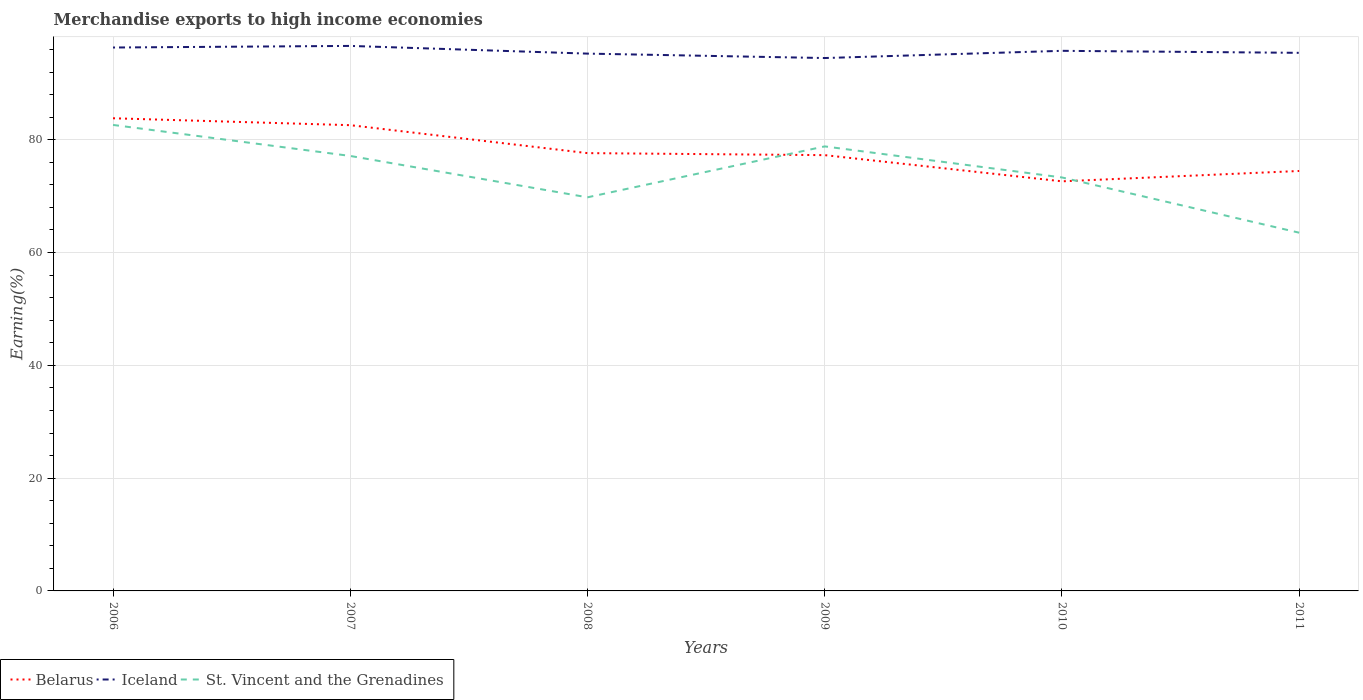How many different coloured lines are there?
Your answer should be very brief. 3. Does the line corresponding to Iceland intersect with the line corresponding to Belarus?
Give a very brief answer. No. Is the number of lines equal to the number of legend labels?
Provide a short and direct response. Yes. Across all years, what is the maximum percentage of amount earned from merchandise exports in Iceland?
Ensure brevity in your answer.  94.49. What is the total percentage of amount earned from merchandise exports in St. Vincent and the Grenadines in the graph?
Give a very brief answer. 19.11. What is the difference between the highest and the second highest percentage of amount earned from merchandise exports in Belarus?
Offer a very short reply. 11.18. What is the difference between the highest and the lowest percentage of amount earned from merchandise exports in Belarus?
Provide a short and direct response. 2. Are the values on the major ticks of Y-axis written in scientific E-notation?
Your response must be concise. No. Does the graph contain any zero values?
Your answer should be very brief. No. What is the title of the graph?
Provide a succinct answer. Merchandise exports to high income economies. What is the label or title of the Y-axis?
Give a very brief answer. Earning(%). What is the Earning(%) in Belarus in 2006?
Offer a terse response. 83.81. What is the Earning(%) in Iceland in 2006?
Provide a short and direct response. 96.35. What is the Earning(%) in St. Vincent and the Grenadines in 2006?
Ensure brevity in your answer.  82.63. What is the Earning(%) in Belarus in 2007?
Ensure brevity in your answer.  82.58. What is the Earning(%) of Iceland in 2007?
Offer a very short reply. 96.64. What is the Earning(%) in St. Vincent and the Grenadines in 2007?
Your answer should be very brief. 77.13. What is the Earning(%) of Belarus in 2008?
Your answer should be compact. 77.63. What is the Earning(%) in Iceland in 2008?
Your answer should be very brief. 95.27. What is the Earning(%) of St. Vincent and the Grenadines in 2008?
Your answer should be very brief. 69.79. What is the Earning(%) of Belarus in 2009?
Ensure brevity in your answer.  77.27. What is the Earning(%) in Iceland in 2009?
Offer a terse response. 94.49. What is the Earning(%) in St. Vincent and the Grenadines in 2009?
Your answer should be compact. 78.82. What is the Earning(%) of Belarus in 2010?
Provide a short and direct response. 72.63. What is the Earning(%) in Iceland in 2010?
Provide a short and direct response. 95.77. What is the Earning(%) in St. Vincent and the Grenadines in 2010?
Ensure brevity in your answer.  73.31. What is the Earning(%) in Belarus in 2011?
Your response must be concise. 74.46. What is the Earning(%) in Iceland in 2011?
Provide a short and direct response. 95.41. What is the Earning(%) of St. Vincent and the Grenadines in 2011?
Provide a short and direct response. 63.52. Across all years, what is the maximum Earning(%) of Belarus?
Give a very brief answer. 83.81. Across all years, what is the maximum Earning(%) in Iceland?
Your response must be concise. 96.64. Across all years, what is the maximum Earning(%) in St. Vincent and the Grenadines?
Your response must be concise. 82.63. Across all years, what is the minimum Earning(%) of Belarus?
Offer a terse response. 72.63. Across all years, what is the minimum Earning(%) in Iceland?
Offer a terse response. 94.49. Across all years, what is the minimum Earning(%) in St. Vincent and the Grenadines?
Keep it short and to the point. 63.52. What is the total Earning(%) of Belarus in the graph?
Give a very brief answer. 468.38. What is the total Earning(%) in Iceland in the graph?
Give a very brief answer. 573.92. What is the total Earning(%) of St. Vincent and the Grenadines in the graph?
Keep it short and to the point. 445.19. What is the difference between the Earning(%) of Belarus in 2006 and that in 2007?
Keep it short and to the point. 1.23. What is the difference between the Earning(%) of Iceland in 2006 and that in 2007?
Provide a succinct answer. -0.28. What is the difference between the Earning(%) in St. Vincent and the Grenadines in 2006 and that in 2007?
Offer a very short reply. 5.5. What is the difference between the Earning(%) in Belarus in 2006 and that in 2008?
Offer a terse response. 6.18. What is the difference between the Earning(%) in Iceland in 2006 and that in 2008?
Your answer should be very brief. 1.08. What is the difference between the Earning(%) in St. Vincent and the Grenadines in 2006 and that in 2008?
Offer a terse response. 12.84. What is the difference between the Earning(%) in Belarus in 2006 and that in 2009?
Offer a very short reply. 6.54. What is the difference between the Earning(%) in Iceland in 2006 and that in 2009?
Keep it short and to the point. 1.87. What is the difference between the Earning(%) in St. Vincent and the Grenadines in 2006 and that in 2009?
Your answer should be compact. 3.81. What is the difference between the Earning(%) in Belarus in 2006 and that in 2010?
Offer a very short reply. 11.18. What is the difference between the Earning(%) in Iceland in 2006 and that in 2010?
Your answer should be very brief. 0.59. What is the difference between the Earning(%) of St. Vincent and the Grenadines in 2006 and that in 2010?
Provide a succinct answer. 9.31. What is the difference between the Earning(%) in Belarus in 2006 and that in 2011?
Your response must be concise. 9.35. What is the difference between the Earning(%) of Iceland in 2006 and that in 2011?
Your answer should be very brief. 0.94. What is the difference between the Earning(%) of St. Vincent and the Grenadines in 2006 and that in 2011?
Make the answer very short. 19.11. What is the difference between the Earning(%) of Belarus in 2007 and that in 2008?
Provide a short and direct response. 4.96. What is the difference between the Earning(%) of Iceland in 2007 and that in 2008?
Make the answer very short. 1.37. What is the difference between the Earning(%) of St. Vincent and the Grenadines in 2007 and that in 2008?
Your answer should be compact. 7.34. What is the difference between the Earning(%) of Belarus in 2007 and that in 2009?
Make the answer very short. 5.31. What is the difference between the Earning(%) in Iceland in 2007 and that in 2009?
Provide a short and direct response. 2.15. What is the difference between the Earning(%) in St. Vincent and the Grenadines in 2007 and that in 2009?
Give a very brief answer. -1.69. What is the difference between the Earning(%) in Belarus in 2007 and that in 2010?
Provide a short and direct response. 9.96. What is the difference between the Earning(%) of Iceland in 2007 and that in 2010?
Your answer should be compact. 0.87. What is the difference between the Earning(%) of St. Vincent and the Grenadines in 2007 and that in 2010?
Your answer should be compact. 3.81. What is the difference between the Earning(%) in Belarus in 2007 and that in 2011?
Offer a terse response. 8.12. What is the difference between the Earning(%) in Iceland in 2007 and that in 2011?
Keep it short and to the point. 1.23. What is the difference between the Earning(%) of St. Vincent and the Grenadines in 2007 and that in 2011?
Make the answer very short. 13.61. What is the difference between the Earning(%) of Belarus in 2008 and that in 2009?
Provide a short and direct response. 0.36. What is the difference between the Earning(%) of Iceland in 2008 and that in 2009?
Ensure brevity in your answer.  0.78. What is the difference between the Earning(%) in St. Vincent and the Grenadines in 2008 and that in 2009?
Keep it short and to the point. -9.03. What is the difference between the Earning(%) of Belarus in 2008 and that in 2010?
Your answer should be very brief. 5. What is the difference between the Earning(%) in Iceland in 2008 and that in 2010?
Ensure brevity in your answer.  -0.49. What is the difference between the Earning(%) of St. Vincent and the Grenadines in 2008 and that in 2010?
Ensure brevity in your answer.  -3.52. What is the difference between the Earning(%) of Belarus in 2008 and that in 2011?
Offer a very short reply. 3.17. What is the difference between the Earning(%) of Iceland in 2008 and that in 2011?
Your answer should be very brief. -0.14. What is the difference between the Earning(%) of St. Vincent and the Grenadines in 2008 and that in 2011?
Your answer should be compact. 6.27. What is the difference between the Earning(%) of Belarus in 2009 and that in 2010?
Provide a short and direct response. 4.64. What is the difference between the Earning(%) of Iceland in 2009 and that in 2010?
Your answer should be compact. -1.28. What is the difference between the Earning(%) of St. Vincent and the Grenadines in 2009 and that in 2010?
Ensure brevity in your answer.  5.51. What is the difference between the Earning(%) of Belarus in 2009 and that in 2011?
Your response must be concise. 2.81. What is the difference between the Earning(%) in Iceland in 2009 and that in 2011?
Make the answer very short. -0.92. What is the difference between the Earning(%) of St. Vincent and the Grenadines in 2009 and that in 2011?
Your response must be concise. 15.3. What is the difference between the Earning(%) in Belarus in 2010 and that in 2011?
Keep it short and to the point. -1.83. What is the difference between the Earning(%) of Iceland in 2010 and that in 2011?
Your answer should be very brief. 0.36. What is the difference between the Earning(%) in St. Vincent and the Grenadines in 2010 and that in 2011?
Provide a short and direct response. 9.8. What is the difference between the Earning(%) in Belarus in 2006 and the Earning(%) in Iceland in 2007?
Keep it short and to the point. -12.83. What is the difference between the Earning(%) in Belarus in 2006 and the Earning(%) in St. Vincent and the Grenadines in 2007?
Your answer should be very brief. 6.68. What is the difference between the Earning(%) in Iceland in 2006 and the Earning(%) in St. Vincent and the Grenadines in 2007?
Give a very brief answer. 19.23. What is the difference between the Earning(%) in Belarus in 2006 and the Earning(%) in Iceland in 2008?
Your response must be concise. -11.46. What is the difference between the Earning(%) in Belarus in 2006 and the Earning(%) in St. Vincent and the Grenadines in 2008?
Offer a very short reply. 14.02. What is the difference between the Earning(%) of Iceland in 2006 and the Earning(%) of St. Vincent and the Grenadines in 2008?
Provide a succinct answer. 26.56. What is the difference between the Earning(%) of Belarus in 2006 and the Earning(%) of Iceland in 2009?
Your answer should be compact. -10.68. What is the difference between the Earning(%) of Belarus in 2006 and the Earning(%) of St. Vincent and the Grenadines in 2009?
Provide a succinct answer. 4.99. What is the difference between the Earning(%) of Iceland in 2006 and the Earning(%) of St. Vincent and the Grenadines in 2009?
Ensure brevity in your answer.  17.53. What is the difference between the Earning(%) in Belarus in 2006 and the Earning(%) in Iceland in 2010?
Your response must be concise. -11.96. What is the difference between the Earning(%) in Belarus in 2006 and the Earning(%) in St. Vincent and the Grenadines in 2010?
Keep it short and to the point. 10.49. What is the difference between the Earning(%) in Iceland in 2006 and the Earning(%) in St. Vincent and the Grenadines in 2010?
Your response must be concise. 23.04. What is the difference between the Earning(%) of Belarus in 2006 and the Earning(%) of Iceland in 2011?
Your answer should be very brief. -11.6. What is the difference between the Earning(%) in Belarus in 2006 and the Earning(%) in St. Vincent and the Grenadines in 2011?
Offer a terse response. 20.29. What is the difference between the Earning(%) of Iceland in 2006 and the Earning(%) of St. Vincent and the Grenadines in 2011?
Your answer should be very brief. 32.84. What is the difference between the Earning(%) in Belarus in 2007 and the Earning(%) in Iceland in 2008?
Give a very brief answer. -12.69. What is the difference between the Earning(%) in Belarus in 2007 and the Earning(%) in St. Vincent and the Grenadines in 2008?
Provide a short and direct response. 12.79. What is the difference between the Earning(%) of Iceland in 2007 and the Earning(%) of St. Vincent and the Grenadines in 2008?
Make the answer very short. 26.85. What is the difference between the Earning(%) in Belarus in 2007 and the Earning(%) in Iceland in 2009?
Your answer should be compact. -11.9. What is the difference between the Earning(%) of Belarus in 2007 and the Earning(%) of St. Vincent and the Grenadines in 2009?
Keep it short and to the point. 3.76. What is the difference between the Earning(%) in Iceland in 2007 and the Earning(%) in St. Vincent and the Grenadines in 2009?
Make the answer very short. 17.82. What is the difference between the Earning(%) in Belarus in 2007 and the Earning(%) in Iceland in 2010?
Offer a very short reply. -13.18. What is the difference between the Earning(%) of Belarus in 2007 and the Earning(%) of St. Vincent and the Grenadines in 2010?
Make the answer very short. 9.27. What is the difference between the Earning(%) of Iceland in 2007 and the Earning(%) of St. Vincent and the Grenadines in 2010?
Provide a succinct answer. 23.32. What is the difference between the Earning(%) in Belarus in 2007 and the Earning(%) in Iceland in 2011?
Make the answer very short. -12.83. What is the difference between the Earning(%) of Belarus in 2007 and the Earning(%) of St. Vincent and the Grenadines in 2011?
Your answer should be compact. 19.07. What is the difference between the Earning(%) of Iceland in 2007 and the Earning(%) of St. Vincent and the Grenadines in 2011?
Ensure brevity in your answer.  33.12. What is the difference between the Earning(%) in Belarus in 2008 and the Earning(%) in Iceland in 2009?
Offer a very short reply. -16.86. What is the difference between the Earning(%) of Belarus in 2008 and the Earning(%) of St. Vincent and the Grenadines in 2009?
Your answer should be very brief. -1.19. What is the difference between the Earning(%) in Iceland in 2008 and the Earning(%) in St. Vincent and the Grenadines in 2009?
Keep it short and to the point. 16.45. What is the difference between the Earning(%) of Belarus in 2008 and the Earning(%) of Iceland in 2010?
Offer a terse response. -18.14. What is the difference between the Earning(%) in Belarus in 2008 and the Earning(%) in St. Vincent and the Grenadines in 2010?
Make the answer very short. 4.31. What is the difference between the Earning(%) of Iceland in 2008 and the Earning(%) of St. Vincent and the Grenadines in 2010?
Keep it short and to the point. 21.96. What is the difference between the Earning(%) of Belarus in 2008 and the Earning(%) of Iceland in 2011?
Your answer should be very brief. -17.78. What is the difference between the Earning(%) of Belarus in 2008 and the Earning(%) of St. Vincent and the Grenadines in 2011?
Provide a short and direct response. 14.11. What is the difference between the Earning(%) of Iceland in 2008 and the Earning(%) of St. Vincent and the Grenadines in 2011?
Offer a very short reply. 31.75. What is the difference between the Earning(%) of Belarus in 2009 and the Earning(%) of Iceland in 2010?
Your answer should be very brief. -18.5. What is the difference between the Earning(%) in Belarus in 2009 and the Earning(%) in St. Vincent and the Grenadines in 2010?
Provide a succinct answer. 3.96. What is the difference between the Earning(%) of Iceland in 2009 and the Earning(%) of St. Vincent and the Grenadines in 2010?
Make the answer very short. 21.17. What is the difference between the Earning(%) in Belarus in 2009 and the Earning(%) in Iceland in 2011?
Make the answer very short. -18.14. What is the difference between the Earning(%) of Belarus in 2009 and the Earning(%) of St. Vincent and the Grenadines in 2011?
Keep it short and to the point. 13.75. What is the difference between the Earning(%) of Iceland in 2009 and the Earning(%) of St. Vincent and the Grenadines in 2011?
Your answer should be very brief. 30.97. What is the difference between the Earning(%) of Belarus in 2010 and the Earning(%) of Iceland in 2011?
Your answer should be very brief. -22.78. What is the difference between the Earning(%) of Belarus in 2010 and the Earning(%) of St. Vincent and the Grenadines in 2011?
Make the answer very short. 9.11. What is the difference between the Earning(%) of Iceland in 2010 and the Earning(%) of St. Vincent and the Grenadines in 2011?
Offer a very short reply. 32.25. What is the average Earning(%) of Belarus per year?
Offer a terse response. 78.06. What is the average Earning(%) in Iceland per year?
Provide a succinct answer. 95.65. What is the average Earning(%) of St. Vincent and the Grenadines per year?
Provide a succinct answer. 74.2. In the year 2006, what is the difference between the Earning(%) of Belarus and Earning(%) of Iceland?
Your response must be concise. -12.54. In the year 2006, what is the difference between the Earning(%) of Belarus and Earning(%) of St. Vincent and the Grenadines?
Your answer should be very brief. 1.18. In the year 2006, what is the difference between the Earning(%) in Iceland and Earning(%) in St. Vincent and the Grenadines?
Offer a terse response. 13.73. In the year 2007, what is the difference between the Earning(%) in Belarus and Earning(%) in Iceland?
Provide a short and direct response. -14.05. In the year 2007, what is the difference between the Earning(%) of Belarus and Earning(%) of St. Vincent and the Grenadines?
Provide a succinct answer. 5.46. In the year 2007, what is the difference between the Earning(%) of Iceland and Earning(%) of St. Vincent and the Grenadines?
Provide a succinct answer. 19.51. In the year 2008, what is the difference between the Earning(%) of Belarus and Earning(%) of Iceland?
Make the answer very short. -17.64. In the year 2008, what is the difference between the Earning(%) in Belarus and Earning(%) in St. Vincent and the Grenadines?
Offer a terse response. 7.84. In the year 2008, what is the difference between the Earning(%) of Iceland and Earning(%) of St. Vincent and the Grenadines?
Your answer should be compact. 25.48. In the year 2009, what is the difference between the Earning(%) of Belarus and Earning(%) of Iceland?
Ensure brevity in your answer.  -17.22. In the year 2009, what is the difference between the Earning(%) of Belarus and Earning(%) of St. Vincent and the Grenadines?
Give a very brief answer. -1.55. In the year 2009, what is the difference between the Earning(%) of Iceland and Earning(%) of St. Vincent and the Grenadines?
Give a very brief answer. 15.67. In the year 2010, what is the difference between the Earning(%) of Belarus and Earning(%) of Iceland?
Ensure brevity in your answer.  -23.14. In the year 2010, what is the difference between the Earning(%) of Belarus and Earning(%) of St. Vincent and the Grenadines?
Provide a short and direct response. -0.69. In the year 2010, what is the difference between the Earning(%) of Iceland and Earning(%) of St. Vincent and the Grenadines?
Your answer should be compact. 22.45. In the year 2011, what is the difference between the Earning(%) in Belarus and Earning(%) in Iceland?
Your answer should be compact. -20.95. In the year 2011, what is the difference between the Earning(%) in Belarus and Earning(%) in St. Vincent and the Grenadines?
Keep it short and to the point. 10.94. In the year 2011, what is the difference between the Earning(%) of Iceland and Earning(%) of St. Vincent and the Grenadines?
Your answer should be compact. 31.89. What is the ratio of the Earning(%) of Belarus in 2006 to that in 2007?
Offer a very short reply. 1.01. What is the ratio of the Earning(%) of Iceland in 2006 to that in 2007?
Make the answer very short. 1. What is the ratio of the Earning(%) in St. Vincent and the Grenadines in 2006 to that in 2007?
Your answer should be very brief. 1.07. What is the ratio of the Earning(%) in Belarus in 2006 to that in 2008?
Your answer should be compact. 1.08. What is the ratio of the Earning(%) of Iceland in 2006 to that in 2008?
Provide a short and direct response. 1.01. What is the ratio of the Earning(%) in St. Vincent and the Grenadines in 2006 to that in 2008?
Give a very brief answer. 1.18. What is the ratio of the Earning(%) of Belarus in 2006 to that in 2009?
Provide a short and direct response. 1.08. What is the ratio of the Earning(%) of Iceland in 2006 to that in 2009?
Give a very brief answer. 1.02. What is the ratio of the Earning(%) in St. Vincent and the Grenadines in 2006 to that in 2009?
Your answer should be compact. 1.05. What is the ratio of the Earning(%) of Belarus in 2006 to that in 2010?
Your answer should be very brief. 1.15. What is the ratio of the Earning(%) in St. Vincent and the Grenadines in 2006 to that in 2010?
Make the answer very short. 1.13. What is the ratio of the Earning(%) in Belarus in 2006 to that in 2011?
Offer a terse response. 1.13. What is the ratio of the Earning(%) of Iceland in 2006 to that in 2011?
Provide a short and direct response. 1.01. What is the ratio of the Earning(%) in St. Vincent and the Grenadines in 2006 to that in 2011?
Provide a succinct answer. 1.3. What is the ratio of the Earning(%) in Belarus in 2007 to that in 2008?
Provide a succinct answer. 1.06. What is the ratio of the Earning(%) in Iceland in 2007 to that in 2008?
Give a very brief answer. 1.01. What is the ratio of the Earning(%) of St. Vincent and the Grenadines in 2007 to that in 2008?
Your answer should be very brief. 1.11. What is the ratio of the Earning(%) of Belarus in 2007 to that in 2009?
Ensure brevity in your answer.  1.07. What is the ratio of the Earning(%) of Iceland in 2007 to that in 2009?
Your response must be concise. 1.02. What is the ratio of the Earning(%) of St. Vincent and the Grenadines in 2007 to that in 2009?
Provide a short and direct response. 0.98. What is the ratio of the Earning(%) in Belarus in 2007 to that in 2010?
Your answer should be very brief. 1.14. What is the ratio of the Earning(%) of Iceland in 2007 to that in 2010?
Your answer should be compact. 1.01. What is the ratio of the Earning(%) of St. Vincent and the Grenadines in 2007 to that in 2010?
Your answer should be very brief. 1.05. What is the ratio of the Earning(%) in Belarus in 2007 to that in 2011?
Offer a very short reply. 1.11. What is the ratio of the Earning(%) in Iceland in 2007 to that in 2011?
Keep it short and to the point. 1.01. What is the ratio of the Earning(%) in St. Vincent and the Grenadines in 2007 to that in 2011?
Your response must be concise. 1.21. What is the ratio of the Earning(%) of Iceland in 2008 to that in 2009?
Offer a very short reply. 1.01. What is the ratio of the Earning(%) in St. Vincent and the Grenadines in 2008 to that in 2009?
Offer a very short reply. 0.89. What is the ratio of the Earning(%) in Belarus in 2008 to that in 2010?
Provide a succinct answer. 1.07. What is the ratio of the Earning(%) of Belarus in 2008 to that in 2011?
Your answer should be very brief. 1.04. What is the ratio of the Earning(%) of Iceland in 2008 to that in 2011?
Offer a terse response. 1. What is the ratio of the Earning(%) of St. Vincent and the Grenadines in 2008 to that in 2011?
Give a very brief answer. 1.1. What is the ratio of the Earning(%) in Belarus in 2009 to that in 2010?
Ensure brevity in your answer.  1.06. What is the ratio of the Earning(%) of Iceland in 2009 to that in 2010?
Your response must be concise. 0.99. What is the ratio of the Earning(%) in St. Vincent and the Grenadines in 2009 to that in 2010?
Keep it short and to the point. 1.08. What is the ratio of the Earning(%) of Belarus in 2009 to that in 2011?
Provide a short and direct response. 1.04. What is the ratio of the Earning(%) in Iceland in 2009 to that in 2011?
Give a very brief answer. 0.99. What is the ratio of the Earning(%) in St. Vincent and the Grenadines in 2009 to that in 2011?
Your answer should be compact. 1.24. What is the ratio of the Earning(%) of Belarus in 2010 to that in 2011?
Your answer should be very brief. 0.98. What is the ratio of the Earning(%) of Iceland in 2010 to that in 2011?
Keep it short and to the point. 1. What is the ratio of the Earning(%) in St. Vincent and the Grenadines in 2010 to that in 2011?
Keep it short and to the point. 1.15. What is the difference between the highest and the second highest Earning(%) of Belarus?
Offer a very short reply. 1.23. What is the difference between the highest and the second highest Earning(%) in Iceland?
Provide a succinct answer. 0.28. What is the difference between the highest and the second highest Earning(%) in St. Vincent and the Grenadines?
Make the answer very short. 3.81. What is the difference between the highest and the lowest Earning(%) in Belarus?
Make the answer very short. 11.18. What is the difference between the highest and the lowest Earning(%) of Iceland?
Offer a terse response. 2.15. What is the difference between the highest and the lowest Earning(%) of St. Vincent and the Grenadines?
Keep it short and to the point. 19.11. 